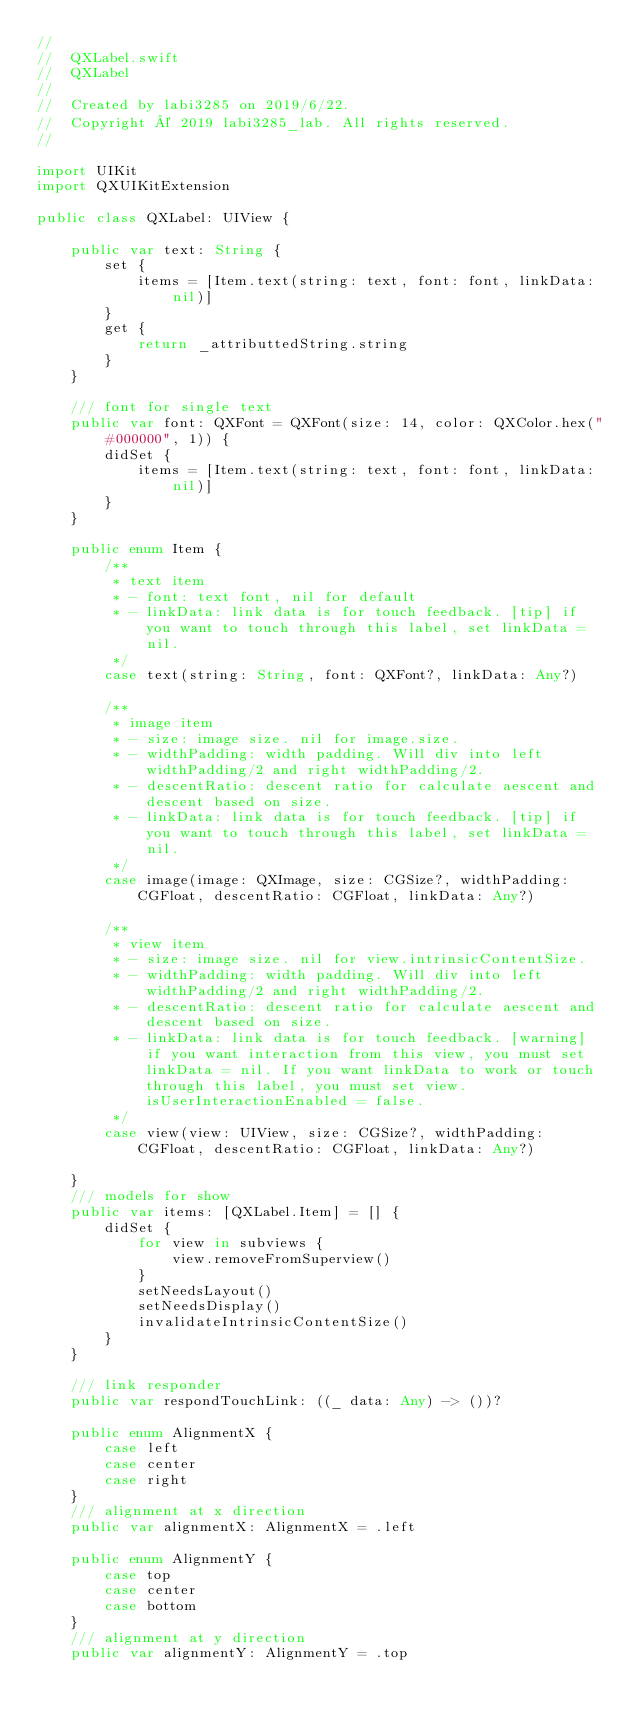<code> <loc_0><loc_0><loc_500><loc_500><_Swift_>//
//  QXLabel.swift
//  QXLabel
//
//  Created by labi3285 on 2019/6/22.
//  Copyright © 2019 labi3285_lab. All rights reserved.
//

import UIKit
import QXUIKitExtension

public class QXLabel: UIView {
    
    public var text: String {
        set {
            items = [Item.text(string: text, font: font, linkData: nil)]
        }
        get {
            return _attributtedString.string
        }
    }
    
    /// font for single text
    public var font: QXFont = QXFont(size: 14, color: QXColor.hex("#000000", 1)) {
        didSet {
            items = [Item.text(string: text, font: font, linkData: nil)]
        }
    }
    
    public enum Item {
        /**
         * text item
         * - font: text font, nil for default
         * - linkData: link data is for touch feedback. [tip] if you want to touch through this label, set linkData = nil.
         */
        case text(string: String, font: QXFont?, linkData: Any?)
        
        /**
         * image item
         * - size: image size. nil for image.size.
         * - widthPadding: width padding. Will div into left widthPadding/2 and right widthPadding/2.
         * - descentRatio: descent ratio for calculate aescent and descent based on size.
         * - linkData: link data is for touch feedback. [tip] if you want to touch through this label, set linkData = nil.
         */
        case image(image: QXImage, size: CGSize?, widthPadding: CGFloat, descentRatio: CGFloat, linkData: Any?)
        
        /**
         * view item
         * - size: image size. nil for view.intrinsicContentSize.
         * - widthPadding: width padding. Will div into left widthPadding/2 and right widthPadding/2.
         * - descentRatio: descent ratio for calculate aescent and descent based on size.
         * - linkData: link data is for touch feedback. [warning] if you want interaction from this view, you must set linkData = nil. If you want linkData to work or touch through this label, you must set view.isUserInteractionEnabled = false.
         */
        case view(view: UIView, size: CGSize?, widthPadding: CGFloat, descentRatio: CGFloat, linkData: Any?)
        
    }
    /// models for show
    public var items: [QXLabel.Item] = [] {
        didSet {
            for view in subviews {
                view.removeFromSuperview()
            }
            setNeedsLayout()
            setNeedsDisplay()
            invalidateIntrinsicContentSize()
        }
    }
    
    /// link responder
    public var respondTouchLink: ((_ data: Any) -> ())?
    
    public enum AlignmentX {
        case left
        case center
        case right
    }
    /// alignment at x direction
    public var alignmentX: AlignmentX = .left
    
    public enum AlignmentY {
        case top
        case center
        case bottom
    }
    /// alignment at y direction
    public var alignmentY: AlignmentY = .top
    </code> 